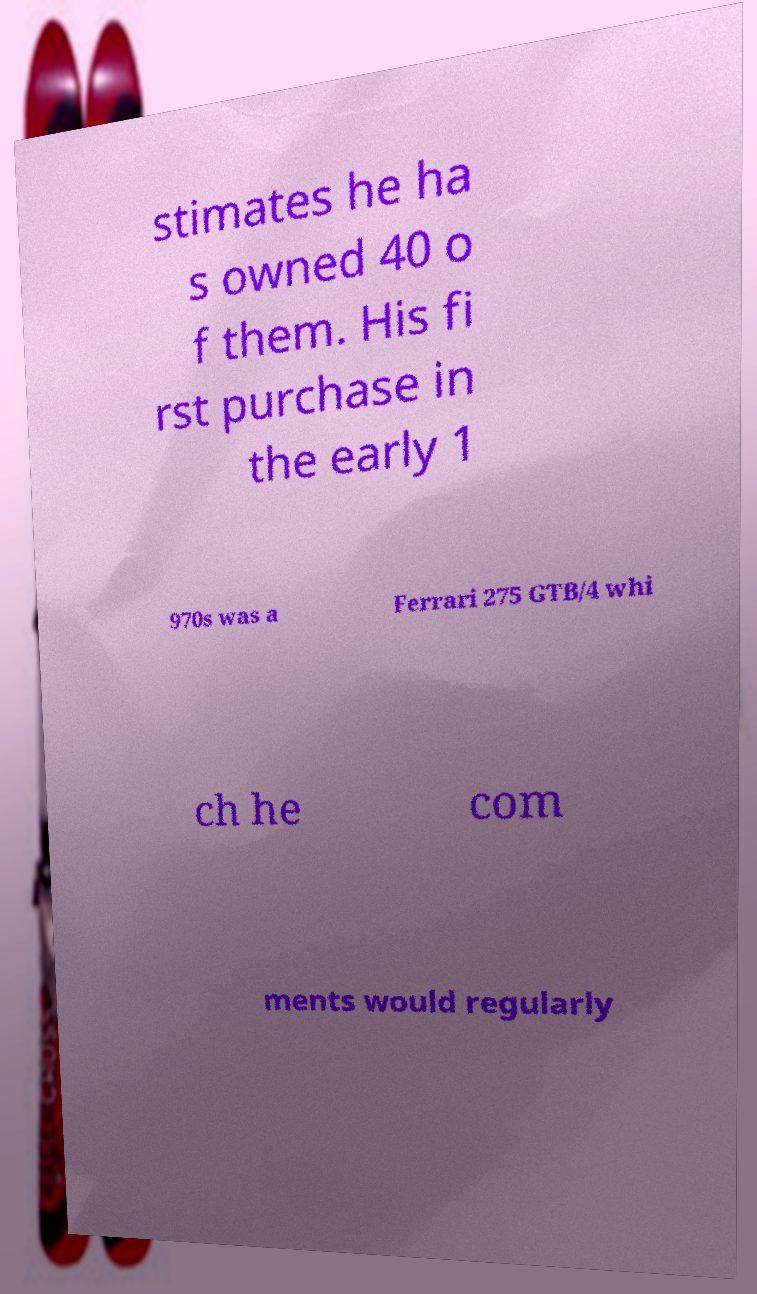For documentation purposes, I need the text within this image transcribed. Could you provide that? stimates he ha s owned 40 o f them. His fi rst purchase in the early 1 970s was a Ferrari 275 GTB/4 whi ch he com ments would regularly 